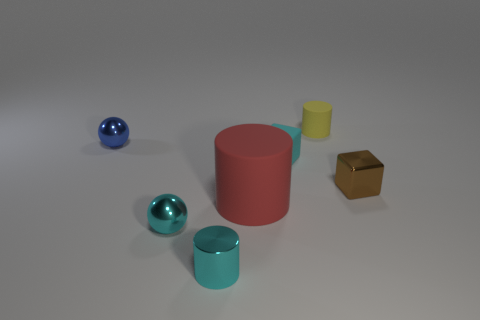What is the color of the tiny cylinder that is in front of the tiny cyan object left of the cyan cylinder?
Keep it short and to the point. Cyan. There is a blue object that is the same size as the brown block; what shape is it?
Ensure brevity in your answer.  Sphere. The matte object that is the same color as the small shiny cylinder is what shape?
Offer a terse response. Cube. Is the number of large rubber cylinders that are behind the yellow rubber cylinder the same as the number of small blue balls?
Your response must be concise. No. What is the material of the block in front of the small rubber object that is in front of the small shiny object that is behind the cyan cube?
Make the answer very short. Metal. What shape is the small brown thing that is made of the same material as the small blue object?
Make the answer very short. Cube. Is there any other thing of the same color as the large matte thing?
Your response must be concise. No. There is a rubber cylinder on the left side of the small cylinder that is behind the small metallic cylinder; what number of tiny cyan metal cylinders are on the right side of it?
Offer a very short reply. 0. How many brown objects are small shiny cylinders or matte objects?
Offer a very short reply. 0. Does the cyan metallic cylinder have the same size as the rubber cylinder that is left of the cyan cube?
Make the answer very short. No. 